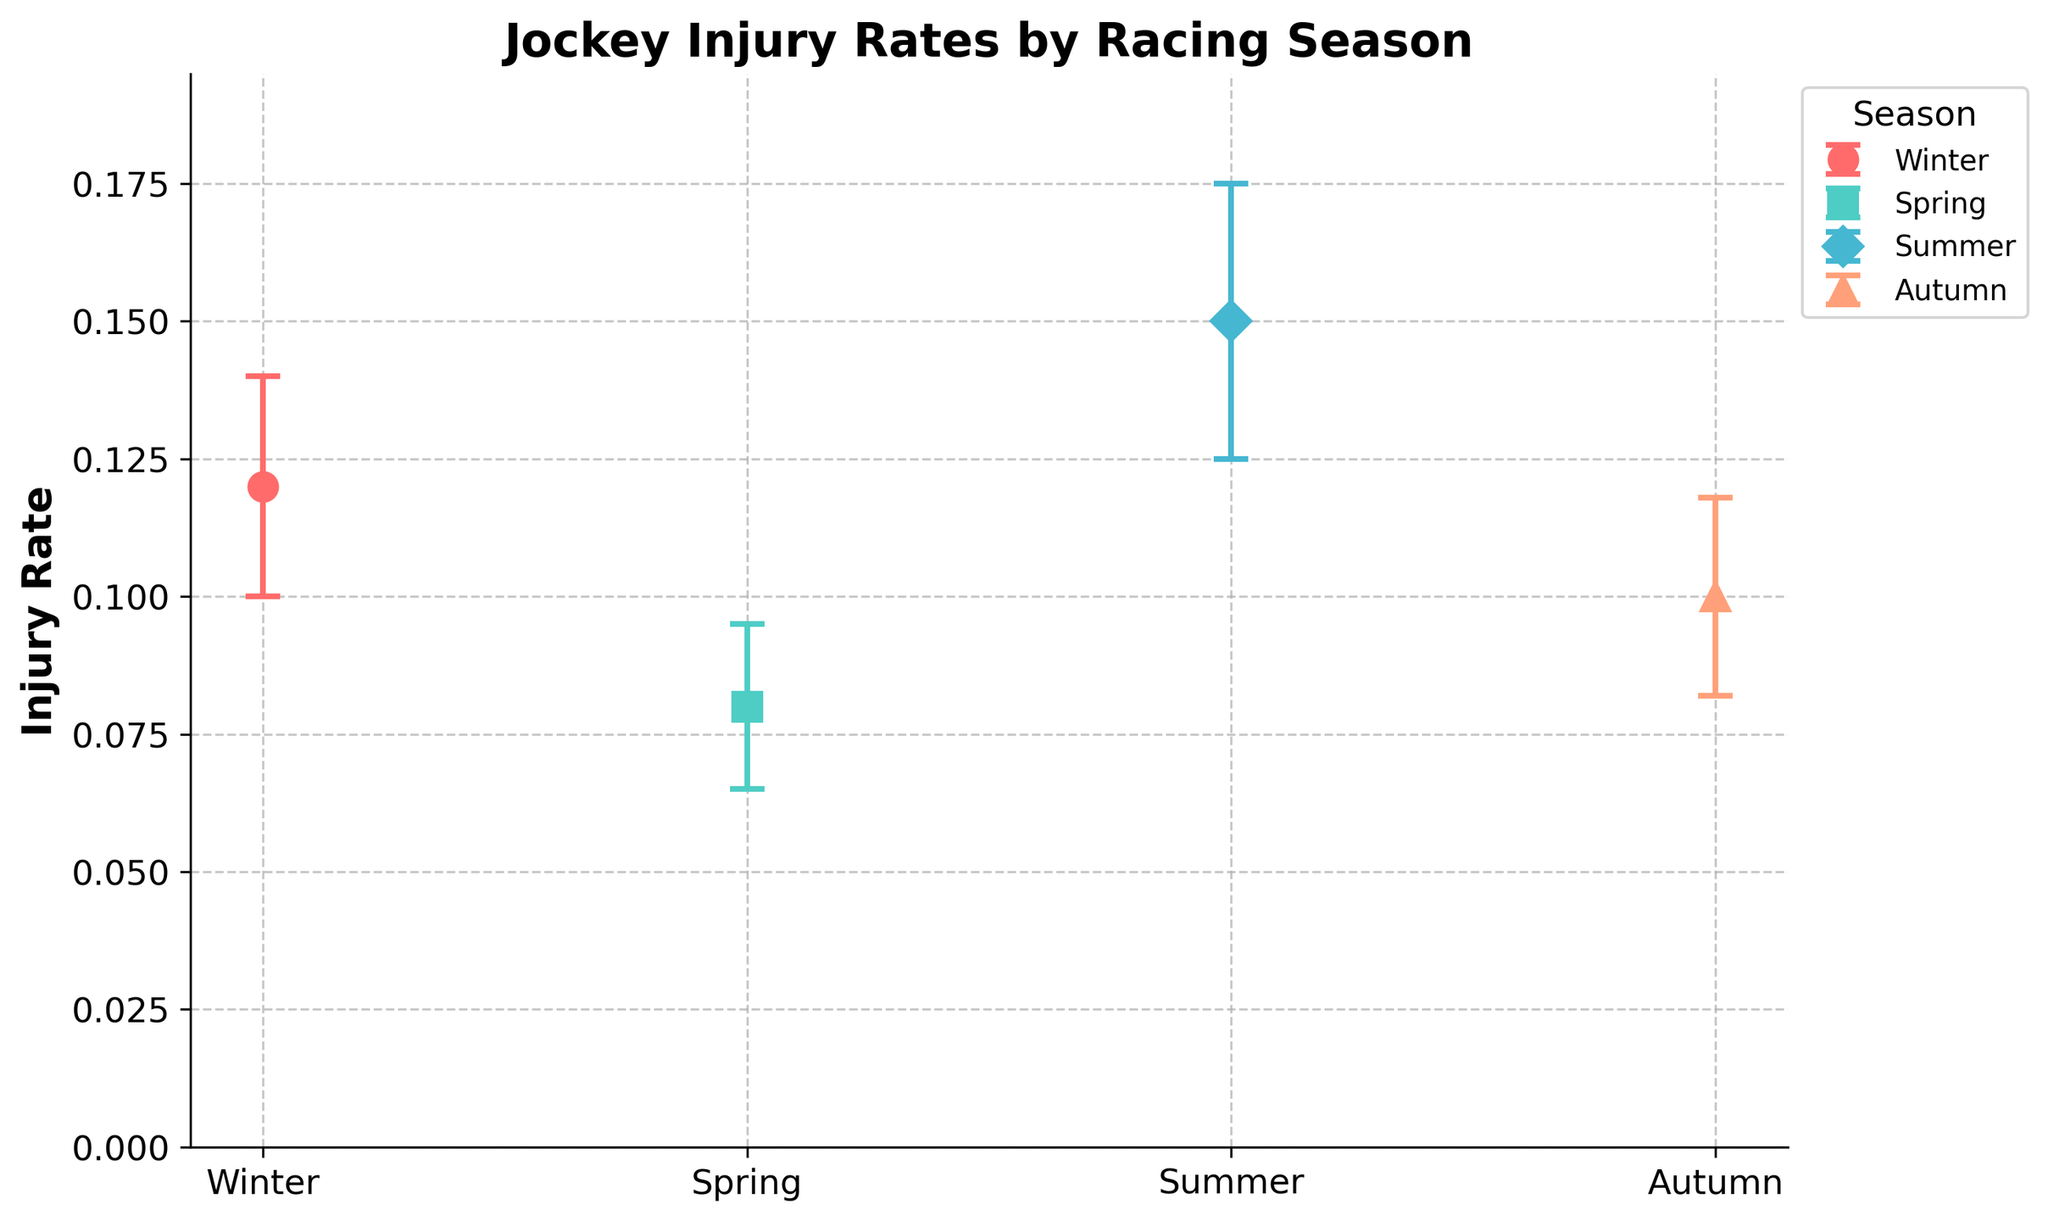What is the highest injury rate reported among the seasons? The highest injury rate can be identified by comparing the values for each season. The injury rates are: Winter (0.12), Spring (0.08), Summer (0.15), and Autumn (0.10). The highest value is 0.15.
Answer: 0.15 Which season has the lowest injury rate? By comparing the injury rates, which are: Winter (0.12), Spring (0.08), Summer (0.15), and Autumn (0.10), the lowest value is 0.08.
Answer: Spring What is the title of the plot? The title of the plot is usually located at the top and provides an overview of the figure's content.
Answer: Jockey Injury Rates by Racing Season Which season has the largest standard deviation in injury rates? By comparing the standard deviations listed: Winter (0.02), Spring (0.015), Summer (0.025), and Autumn (0.018), the largest value is 0.025.
Answer: Summer What is the injury rate for Autumn? Review the data points on the plot for the Autumn season. The rate is 0.10 as indicated.
Answer: 0.10 Calculate the average injury rate across all seasons. Sum the injury rates: Winter (0.12) + Spring (0.08) + Summer (0.15) + Autumn (0.10) = 0.45. Then divide by the number of seasons: 0.45 / 4 = 0.1125.
Answer: 0.1125 Which two seasons have the smallest difference in injury rates? Calculate the differences: Winter-Spring (0.12-0.08=0.04), Winter-Summer (0.15-0.12=0.03), Winter-Autumn (0.12-0.10=0.02), Spring-Summer (0.15-0.08=0.07), Spring-Autumn (0.10-0.08=0.02), and Summer-Autumn (0.15-0.10=0.05). The smallest differences are Winter and Autumn, Spring and Autumn, which both have a difference of 0.02.
Answer: Winter and Autumn, Spring and Autumn Does Spring have a higher or lower injury rate than Summer? Compare the injury rates for Spring (0.08) and Summer (0.15). Spring's injury rate is lower.
Answer: Lower What is the range of injury rates across the seasons? The range is found by subtracting the smallest injury rate from the largest. The highest rate is 0.15 (Summer) and the lowest is 0.08 (Spring). Calculate: 0.15 - 0.08 = 0.07.
Answer: 0.07 Does the injury rate appear to increase or decrease from Spring to Summer? By comparing the injury rates for Spring (0.08) and Summer (0.15), it's clear that the rate increases.
Answer: Increases 